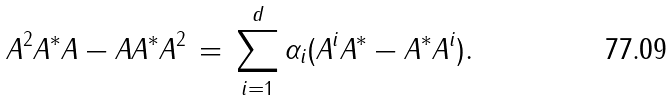<formula> <loc_0><loc_0><loc_500><loc_500>A ^ { 2 } A ^ { * } A - A A ^ { * } A ^ { 2 } \, = \, \sum _ { i = 1 } ^ { d } \alpha _ { i } ( A ^ { i } A ^ { * } - A ^ { * } A ^ { i } ) .</formula> 